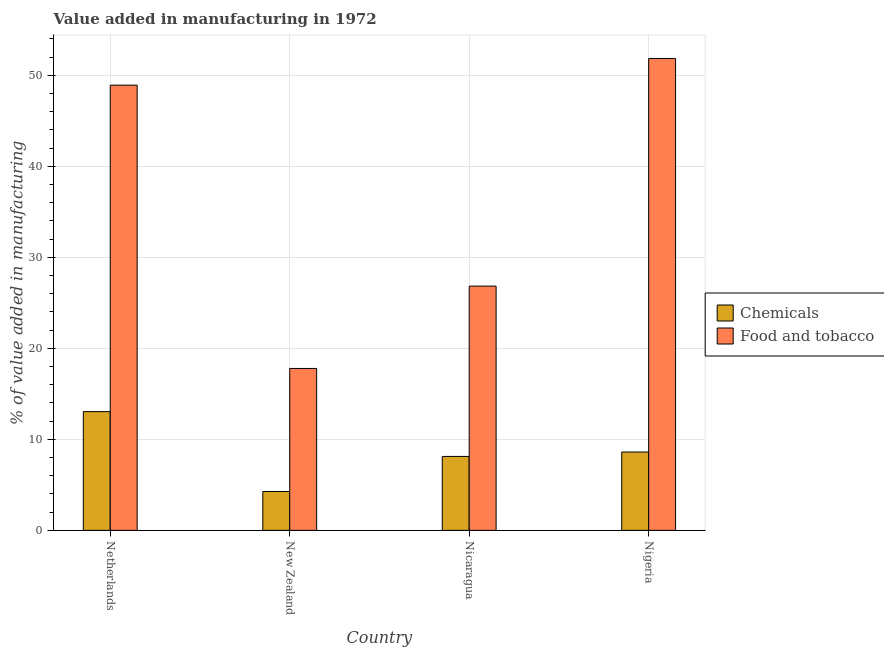How many groups of bars are there?
Offer a terse response. 4. What is the label of the 2nd group of bars from the left?
Your answer should be compact. New Zealand. What is the value added by manufacturing food and tobacco in Netherlands?
Offer a very short reply. 48.92. Across all countries, what is the maximum value added by manufacturing food and tobacco?
Make the answer very short. 51.85. Across all countries, what is the minimum value added by  manufacturing chemicals?
Provide a succinct answer. 4.27. In which country was the value added by manufacturing food and tobacco maximum?
Your response must be concise. Nigeria. In which country was the value added by  manufacturing chemicals minimum?
Your response must be concise. New Zealand. What is the total value added by manufacturing food and tobacco in the graph?
Give a very brief answer. 145.4. What is the difference between the value added by manufacturing food and tobacco in Netherlands and that in Nigeria?
Ensure brevity in your answer.  -2.93. What is the difference between the value added by  manufacturing chemicals in Nicaragua and the value added by manufacturing food and tobacco in Nigeria?
Your response must be concise. -43.73. What is the average value added by manufacturing food and tobacco per country?
Give a very brief answer. 36.35. What is the difference between the value added by manufacturing food and tobacco and value added by  manufacturing chemicals in New Zealand?
Make the answer very short. 13.52. In how many countries, is the value added by manufacturing food and tobacco greater than 20 %?
Keep it short and to the point. 3. What is the ratio of the value added by  manufacturing chemicals in New Zealand to that in Nigeria?
Offer a very short reply. 0.5. Is the difference between the value added by manufacturing food and tobacco in Netherlands and Nicaragua greater than the difference between the value added by  manufacturing chemicals in Netherlands and Nicaragua?
Your answer should be compact. Yes. What is the difference between the highest and the second highest value added by  manufacturing chemicals?
Give a very brief answer. 4.44. What is the difference between the highest and the lowest value added by  manufacturing chemicals?
Provide a succinct answer. 8.77. Is the sum of the value added by  manufacturing chemicals in Nicaragua and Nigeria greater than the maximum value added by manufacturing food and tobacco across all countries?
Provide a succinct answer. No. What does the 2nd bar from the left in Nicaragua represents?
Provide a short and direct response. Food and tobacco. What does the 2nd bar from the right in Nigeria represents?
Make the answer very short. Chemicals. How many bars are there?
Provide a succinct answer. 8. Are all the bars in the graph horizontal?
Offer a very short reply. No. How many countries are there in the graph?
Offer a terse response. 4. What is the difference between two consecutive major ticks on the Y-axis?
Offer a terse response. 10. Does the graph contain any zero values?
Ensure brevity in your answer.  No. Where does the legend appear in the graph?
Make the answer very short. Center right. What is the title of the graph?
Offer a terse response. Value added in manufacturing in 1972. Does "GDP at market prices" appear as one of the legend labels in the graph?
Offer a very short reply. No. What is the label or title of the X-axis?
Provide a short and direct response. Country. What is the label or title of the Y-axis?
Your answer should be very brief. % of value added in manufacturing. What is the % of value added in manufacturing of Chemicals in Netherlands?
Keep it short and to the point. 13.05. What is the % of value added in manufacturing of Food and tobacco in Netherlands?
Provide a succinct answer. 48.92. What is the % of value added in manufacturing of Chemicals in New Zealand?
Ensure brevity in your answer.  4.27. What is the % of value added in manufacturing of Food and tobacco in New Zealand?
Your answer should be compact. 17.79. What is the % of value added in manufacturing in Chemicals in Nicaragua?
Ensure brevity in your answer.  8.13. What is the % of value added in manufacturing in Food and tobacco in Nicaragua?
Make the answer very short. 26.84. What is the % of value added in manufacturing of Chemicals in Nigeria?
Keep it short and to the point. 8.61. What is the % of value added in manufacturing in Food and tobacco in Nigeria?
Make the answer very short. 51.85. Across all countries, what is the maximum % of value added in manufacturing in Chemicals?
Ensure brevity in your answer.  13.05. Across all countries, what is the maximum % of value added in manufacturing of Food and tobacco?
Ensure brevity in your answer.  51.85. Across all countries, what is the minimum % of value added in manufacturing of Chemicals?
Offer a very short reply. 4.27. Across all countries, what is the minimum % of value added in manufacturing in Food and tobacco?
Offer a terse response. 17.79. What is the total % of value added in manufacturing in Chemicals in the graph?
Keep it short and to the point. 34.06. What is the total % of value added in manufacturing of Food and tobacco in the graph?
Give a very brief answer. 145.4. What is the difference between the % of value added in manufacturing in Chemicals in Netherlands and that in New Zealand?
Offer a very short reply. 8.77. What is the difference between the % of value added in manufacturing of Food and tobacco in Netherlands and that in New Zealand?
Provide a short and direct response. 31.13. What is the difference between the % of value added in manufacturing of Chemicals in Netherlands and that in Nicaragua?
Provide a succinct answer. 4.92. What is the difference between the % of value added in manufacturing of Food and tobacco in Netherlands and that in Nicaragua?
Offer a terse response. 22.08. What is the difference between the % of value added in manufacturing of Chemicals in Netherlands and that in Nigeria?
Provide a succinct answer. 4.44. What is the difference between the % of value added in manufacturing in Food and tobacco in Netherlands and that in Nigeria?
Make the answer very short. -2.93. What is the difference between the % of value added in manufacturing of Chemicals in New Zealand and that in Nicaragua?
Make the answer very short. -3.85. What is the difference between the % of value added in manufacturing in Food and tobacco in New Zealand and that in Nicaragua?
Offer a very short reply. -9.05. What is the difference between the % of value added in manufacturing of Chemicals in New Zealand and that in Nigeria?
Keep it short and to the point. -4.34. What is the difference between the % of value added in manufacturing of Food and tobacco in New Zealand and that in Nigeria?
Your answer should be compact. -34.06. What is the difference between the % of value added in manufacturing in Chemicals in Nicaragua and that in Nigeria?
Offer a terse response. -0.49. What is the difference between the % of value added in manufacturing in Food and tobacco in Nicaragua and that in Nigeria?
Give a very brief answer. -25.01. What is the difference between the % of value added in manufacturing of Chemicals in Netherlands and the % of value added in manufacturing of Food and tobacco in New Zealand?
Keep it short and to the point. -4.74. What is the difference between the % of value added in manufacturing of Chemicals in Netherlands and the % of value added in manufacturing of Food and tobacco in Nicaragua?
Offer a terse response. -13.79. What is the difference between the % of value added in manufacturing in Chemicals in Netherlands and the % of value added in manufacturing in Food and tobacco in Nigeria?
Your answer should be compact. -38.8. What is the difference between the % of value added in manufacturing in Chemicals in New Zealand and the % of value added in manufacturing in Food and tobacco in Nicaragua?
Keep it short and to the point. -22.56. What is the difference between the % of value added in manufacturing of Chemicals in New Zealand and the % of value added in manufacturing of Food and tobacco in Nigeria?
Your answer should be compact. -47.58. What is the difference between the % of value added in manufacturing of Chemicals in Nicaragua and the % of value added in manufacturing of Food and tobacco in Nigeria?
Your response must be concise. -43.73. What is the average % of value added in manufacturing of Chemicals per country?
Your response must be concise. 8.52. What is the average % of value added in manufacturing in Food and tobacco per country?
Your answer should be compact. 36.35. What is the difference between the % of value added in manufacturing in Chemicals and % of value added in manufacturing in Food and tobacco in Netherlands?
Give a very brief answer. -35.87. What is the difference between the % of value added in manufacturing of Chemicals and % of value added in manufacturing of Food and tobacco in New Zealand?
Provide a short and direct response. -13.52. What is the difference between the % of value added in manufacturing in Chemicals and % of value added in manufacturing in Food and tobacco in Nicaragua?
Offer a very short reply. -18.71. What is the difference between the % of value added in manufacturing in Chemicals and % of value added in manufacturing in Food and tobacco in Nigeria?
Offer a very short reply. -43.24. What is the ratio of the % of value added in manufacturing in Chemicals in Netherlands to that in New Zealand?
Your response must be concise. 3.05. What is the ratio of the % of value added in manufacturing of Food and tobacco in Netherlands to that in New Zealand?
Your answer should be very brief. 2.75. What is the ratio of the % of value added in manufacturing in Chemicals in Netherlands to that in Nicaragua?
Ensure brevity in your answer.  1.61. What is the ratio of the % of value added in manufacturing in Food and tobacco in Netherlands to that in Nicaragua?
Your answer should be very brief. 1.82. What is the ratio of the % of value added in manufacturing of Chemicals in Netherlands to that in Nigeria?
Keep it short and to the point. 1.52. What is the ratio of the % of value added in manufacturing of Food and tobacco in Netherlands to that in Nigeria?
Offer a very short reply. 0.94. What is the ratio of the % of value added in manufacturing in Chemicals in New Zealand to that in Nicaragua?
Your answer should be very brief. 0.53. What is the ratio of the % of value added in manufacturing of Food and tobacco in New Zealand to that in Nicaragua?
Give a very brief answer. 0.66. What is the ratio of the % of value added in manufacturing of Chemicals in New Zealand to that in Nigeria?
Provide a short and direct response. 0.5. What is the ratio of the % of value added in manufacturing of Food and tobacco in New Zealand to that in Nigeria?
Make the answer very short. 0.34. What is the ratio of the % of value added in manufacturing of Chemicals in Nicaragua to that in Nigeria?
Give a very brief answer. 0.94. What is the ratio of the % of value added in manufacturing of Food and tobacco in Nicaragua to that in Nigeria?
Provide a succinct answer. 0.52. What is the difference between the highest and the second highest % of value added in manufacturing of Chemicals?
Ensure brevity in your answer.  4.44. What is the difference between the highest and the second highest % of value added in manufacturing of Food and tobacco?
Offer a very short reply. 2.93. What is the difference between the highest and the lowest % of value added in manufacturing of Chemicals?
Ensure brevity in your answer.  8.77. What is the difference between the highest and the lowest % of value added in manufacturing of Food and tobacco?
Your answer should be very brief. 34.06. 